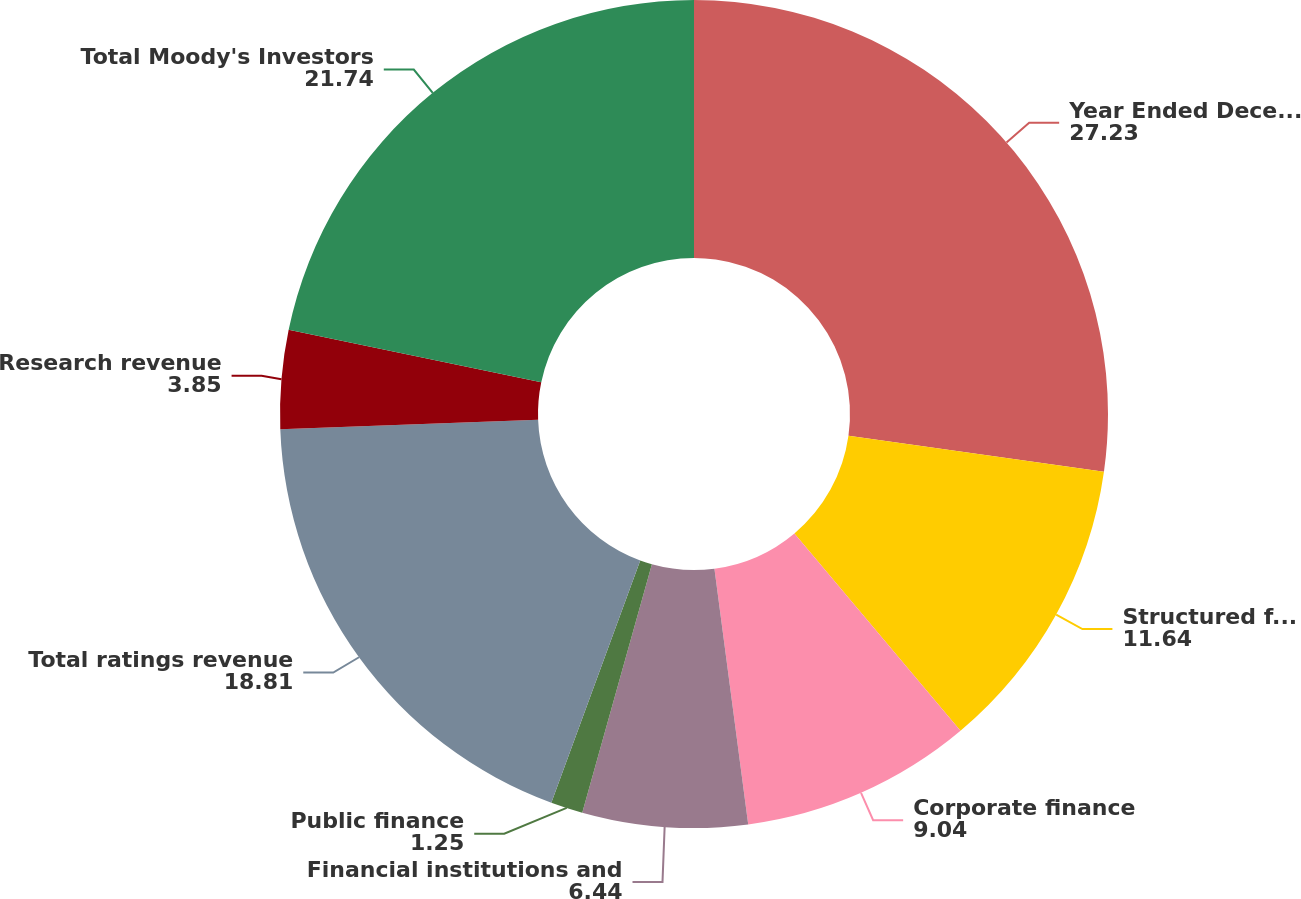Convert chart to OTSL. <chart><loc_0><loc_0><loc_500><loc_500><pie_chart><fcel>Year Ended December 31<fcel>Structured finance<fcel>Corporate finance<fcel>Financial institutions and<fcel>Public finance<fcel>Total ratings revenue<fcel>Research revenue<fcel>Total Moody's Investors<nl><fcel>27.23%<fcel>11.64%<fcel>9.04%<fcel>6.44%<fcel>1.25%<fcel>18.81%<fcel>3.85%<fcel>21.74%<nl></chart> 